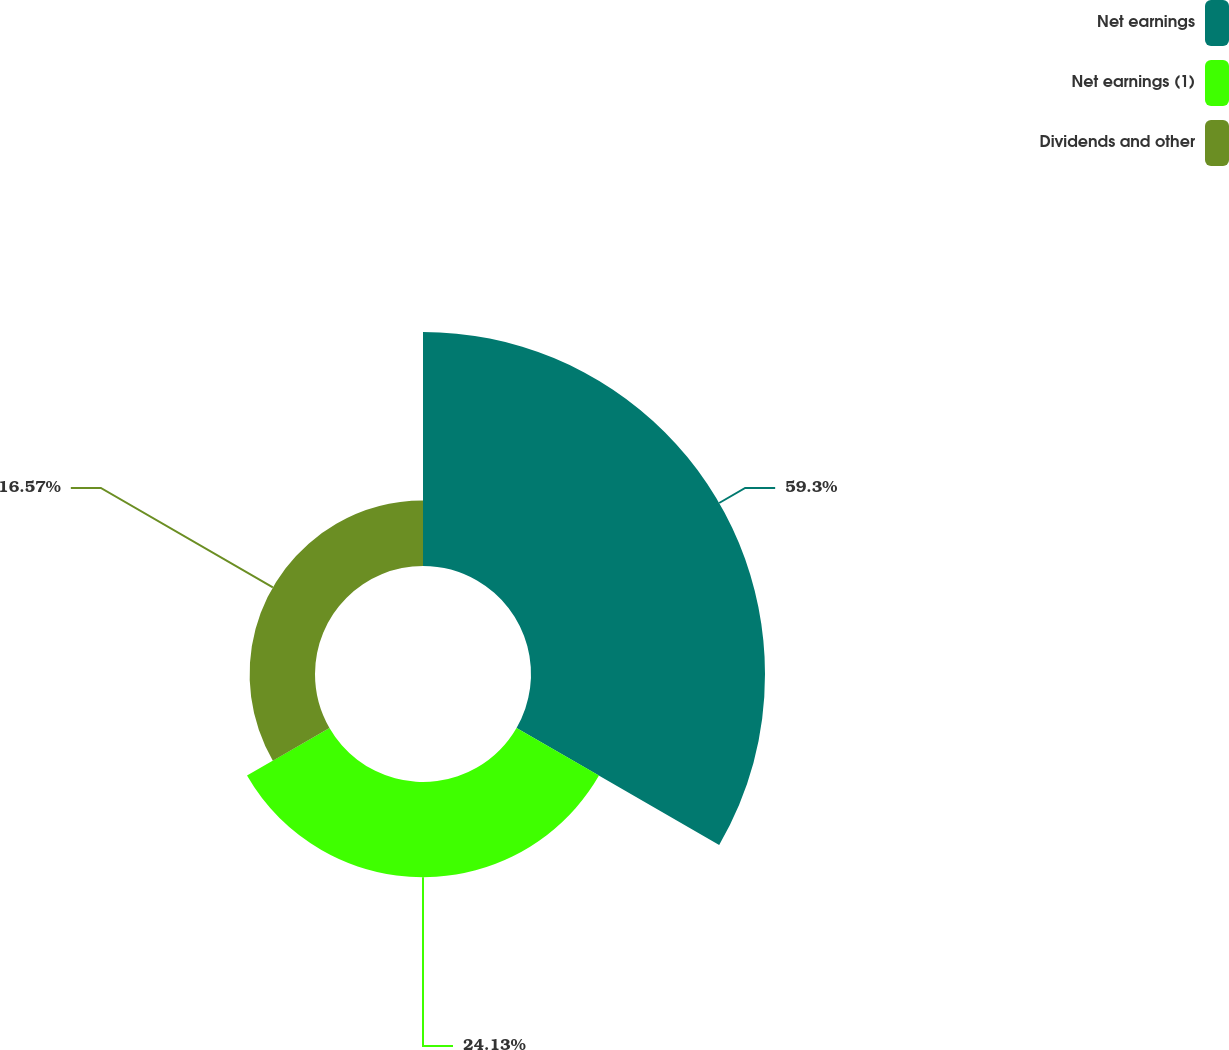Convert chart to OTSL. <chart><loc_0><loc_0><loc_500><loc_500><pie_chart><fcel>Net earnings<fcel>Net earnings (1)<fcel>Dividends and other<nl><fcel>59.3%<fcel>24.13%<fcel>16.57%<nl></chart> 